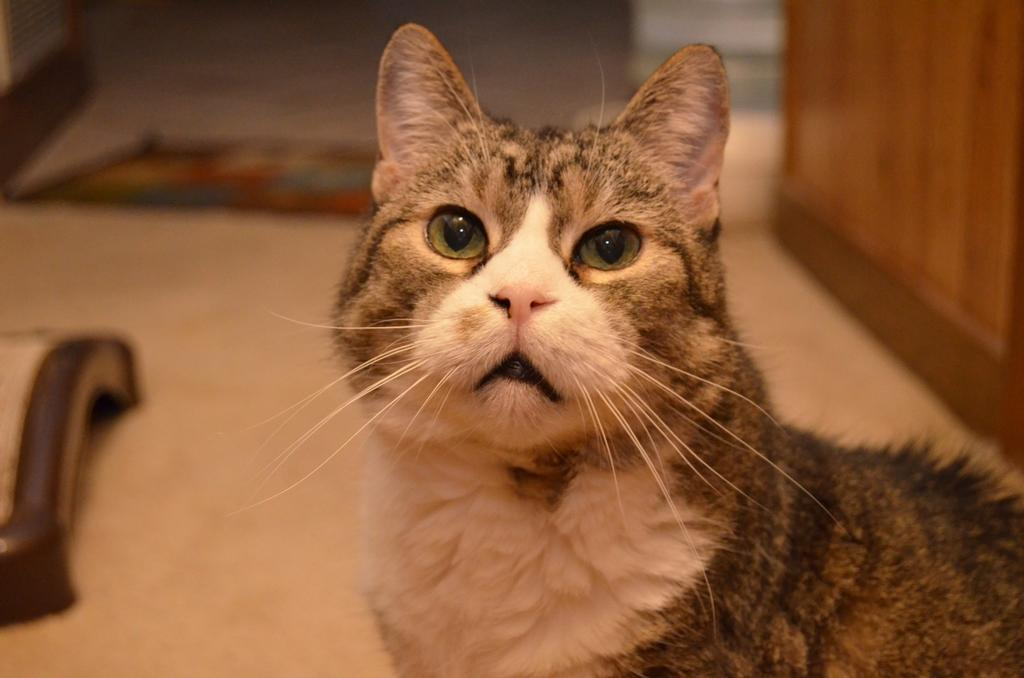What type of animal is in the image? There is a cat in the image. Where is the cat positioned in the image? The cat is standing on the floor. Can you describe the background of the image? The background of the image is blurred. What type of popcorn is being served by the band in the image? There is no band or popcorn present in the image; it features a cat standing on the floor with a blurred background. 